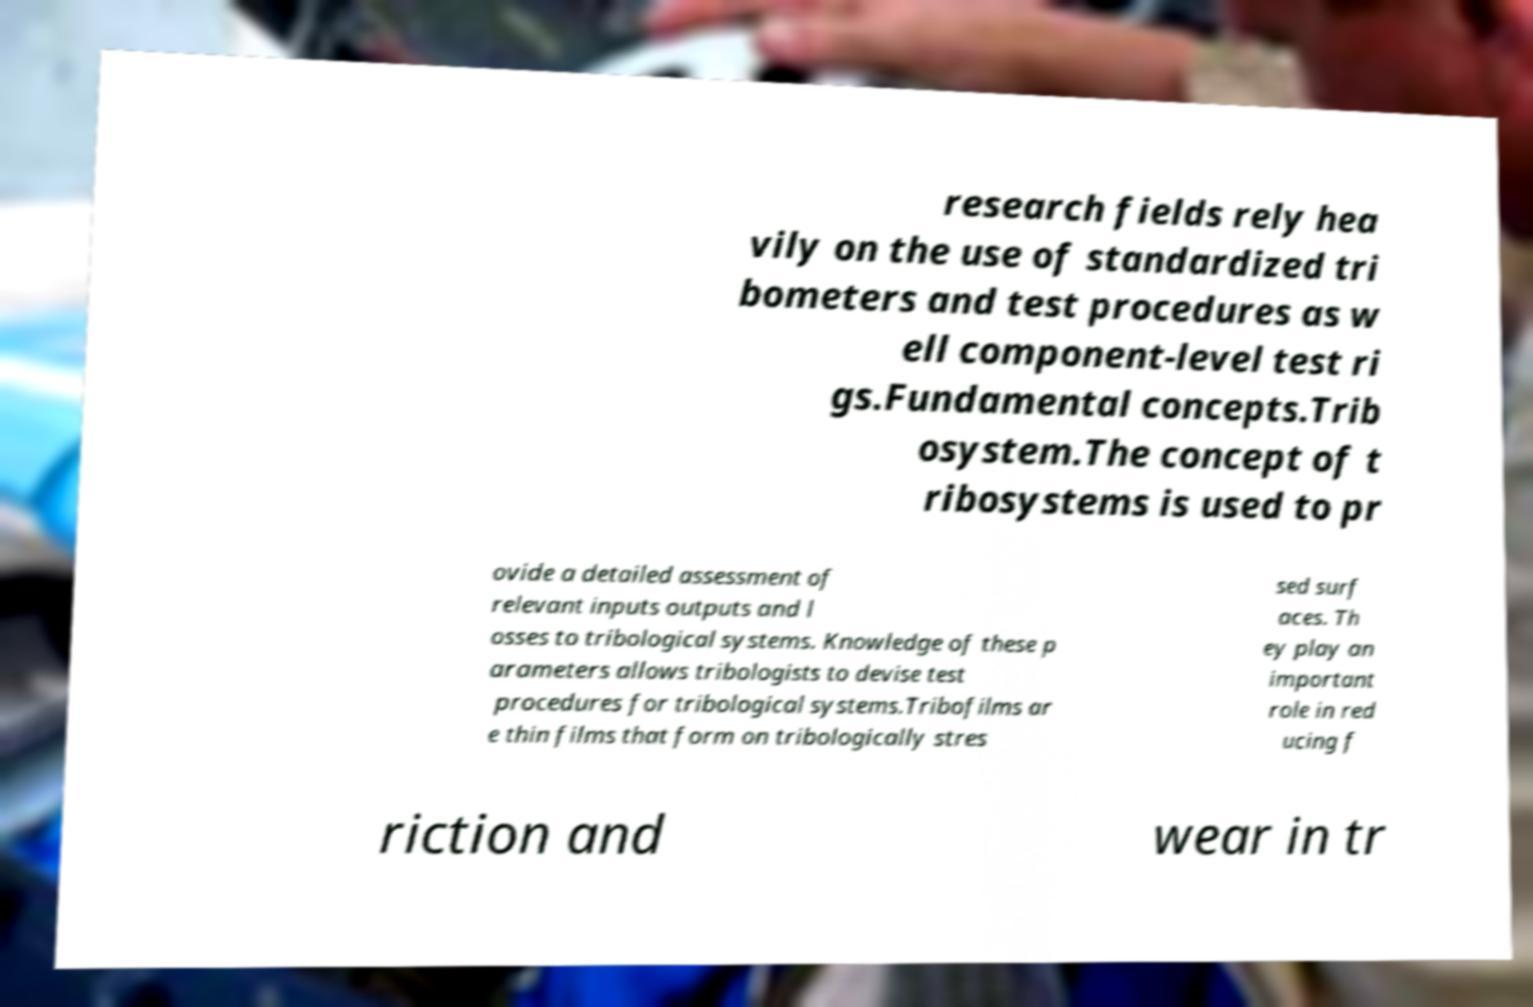Can you accurately transcribe the text from the provided image for me? research fields rely hea vily on the use of standardized tri bometers and test procedures as w ell component-level test ri gs.Fundamental concepts.Trib osystem.The concept of t ribosystems is used to pr ovide a detailed assessment of relevant inputs outputs and l osses to tribological systems. Knowledge of these p arameters allows tribologists to devise test procedures for tribological systems.Tribofilms ar e thin films that form on tribologically stres sed surf aces. Th ey play an important role in red ucing f riction and wear in tr 